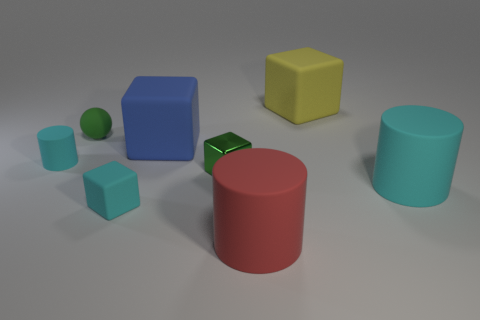Are there any other things that are the same material as the small green block?
Offer a very short reply. No. Is there any other thing that is the same shape as the tiny green matte object?
Offer a very short reply. No. There is a green metal object; is it the same size as the matte cylinder that is left of the green rubber thing?
Ensure brevity in your answer.  Yes. Does the tiny object that is in front of the green block have the same material as the cylinder that is on the left side of the green shiny object?
Provide a short and direct response. Yes. What is the small green cube made of?
Provide a short and direct response. Metal. Is the number of small green metallic cubes that are behind the large yellow matte block greater than the number of metal things?
Make the answer very short. No. What number of matte cylinders are in front of the large block that is to the right of the big red rubber object in front of the tiny matte cube?
Offer a very short reply. 3. There is a cyan object that is left of the yellow object and in front of the tiny cyan cylinder; what is its material?
Offer a very short reply. Rubber. The small rubber sphere has what color?
Your response must be concise. Green. Is the number of cyan matte blocks behind the large yellow block greater than the number of cyan matte cylinders right of the red matte cylinder?
Ensure brevity in your answer.  No. 